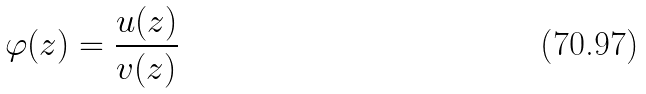Convert formula to latex. <formula><loc_0><loc_0><loc_500><loc_500>\varphi ( z ) = \frac { u ( z ) } { v ( z ) }</formula> 